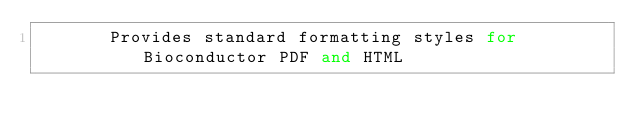<code> <loc_0><loc_0><loc_500><loc_500><_Python_>       Provides standard formatting styles for Bioconductor PDF and HTML</code> 